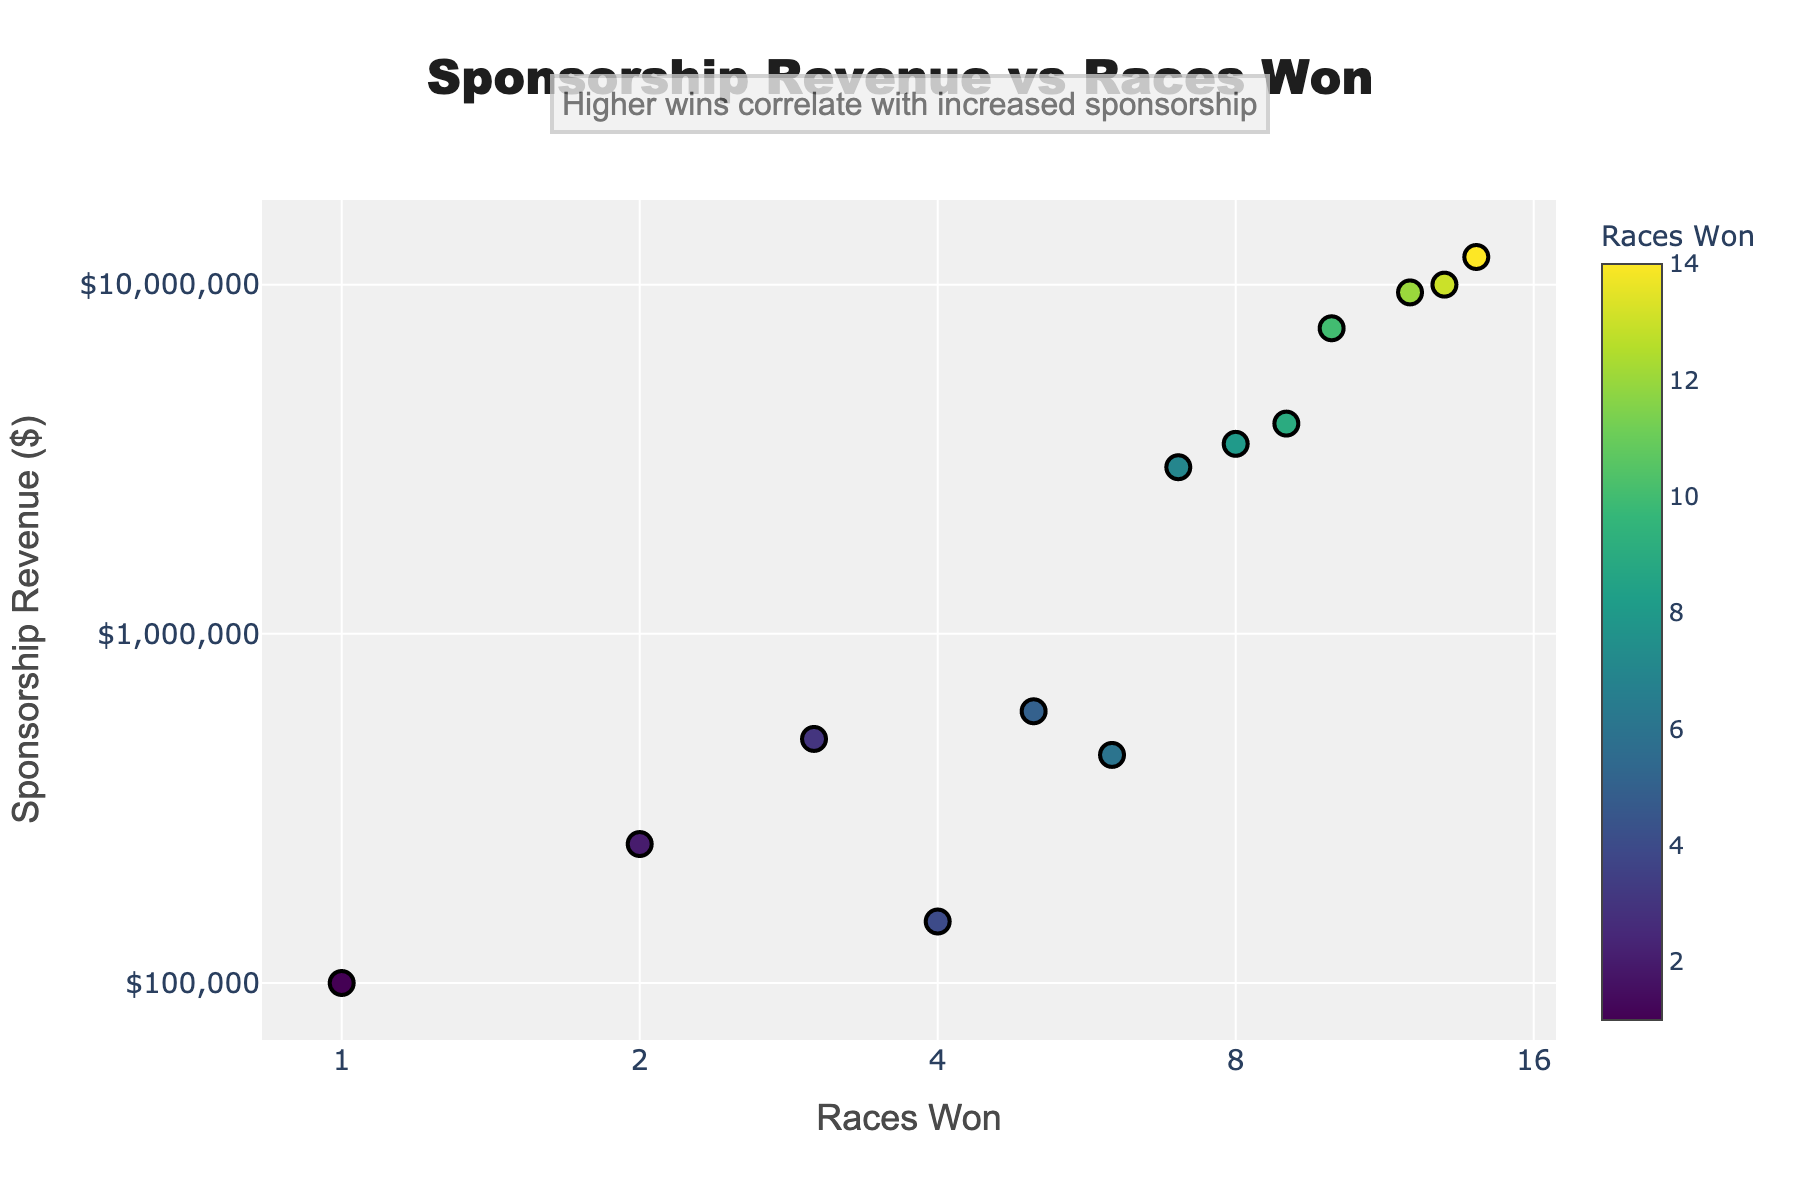What's the title of the figure? The title is centrally placed at the top of the figure and provides an overview of what the scatter plot represents.
Answer: Sponsorship Revenue vs Races Won What are the labels of the X and Y axes? The labels provide crucial information about the data axes. The X-axis is labeled "Races Won" and the Y-axis is labeled "Sponsorship Revenue ($)".
Answer: "Races Won" and "Sponsorship Revenue ($)" How many data points are displayed in the scatter plot? You can count the markers on the plot; each marker represents a data point.
Answer: 13 What is the general pattern observed in the plot? By observing the placement of data points, one can conclude the overall trend. The annotation in the plot also helps to understand the correlation.
Answer: Higher number of races won correlates with increased sponsorship revenue Which racer has the highest sponsorship revenue and how many races did they win? Find the point highest on the Y-axis and refer to its X-axis value as well. The data can also be confirmed through annotation text shown on hover.
Answer: 14 races won, $12,000,000 revenue What is the relationship between races won and the sponsorship revenue? By looking at the scatter plot and the annotation, you can see a pattern suggesting a positive correlation.
Answer: Positive correlation Which racer with the least races won still managed to get sponsorship revenue above $100,000? Identify the point with the fewest races but still having a Y value indicating sponsorship above $100,000.
Answer: 1 race won, $100,000 revenue What is the sponsorship revenue for the racer who won 6 races? Find the data point on the plot where X-axis value is 6, then read the Y-axis value connected to it.
Answer: $450,000 Is the sponsorship revenue growing exponentially with the number of races won? Given that both axes are on a log scale, an exponential growth would appear linear. By observing the plot, you can see an upward trend that might indicate exponential growth.
Answer: Yes, it appears exponential 